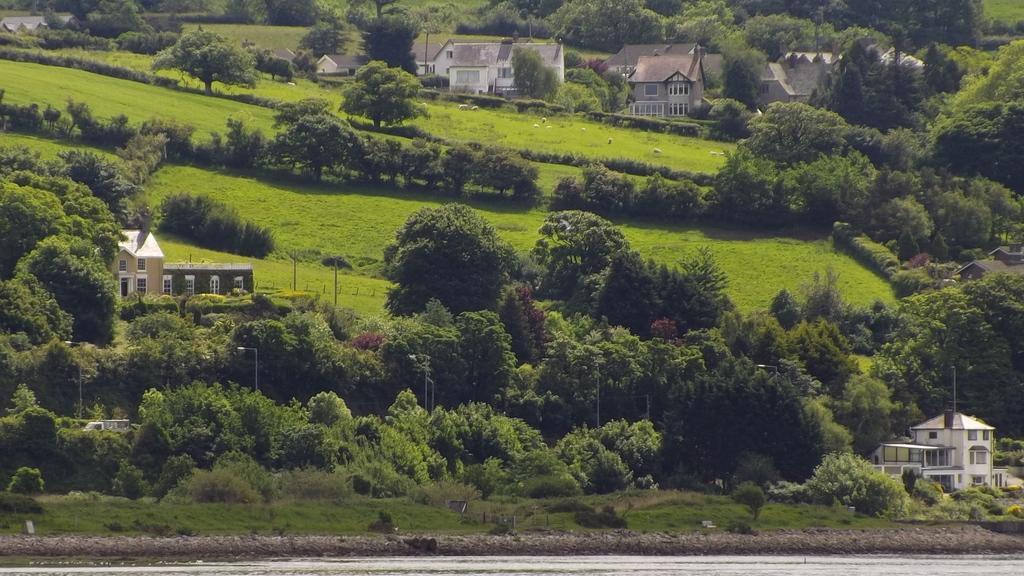Could you give a brief overview of what you see in this image? In this image there are some buildings surrounded with so many trees and some animals eating the grass at the middle. 